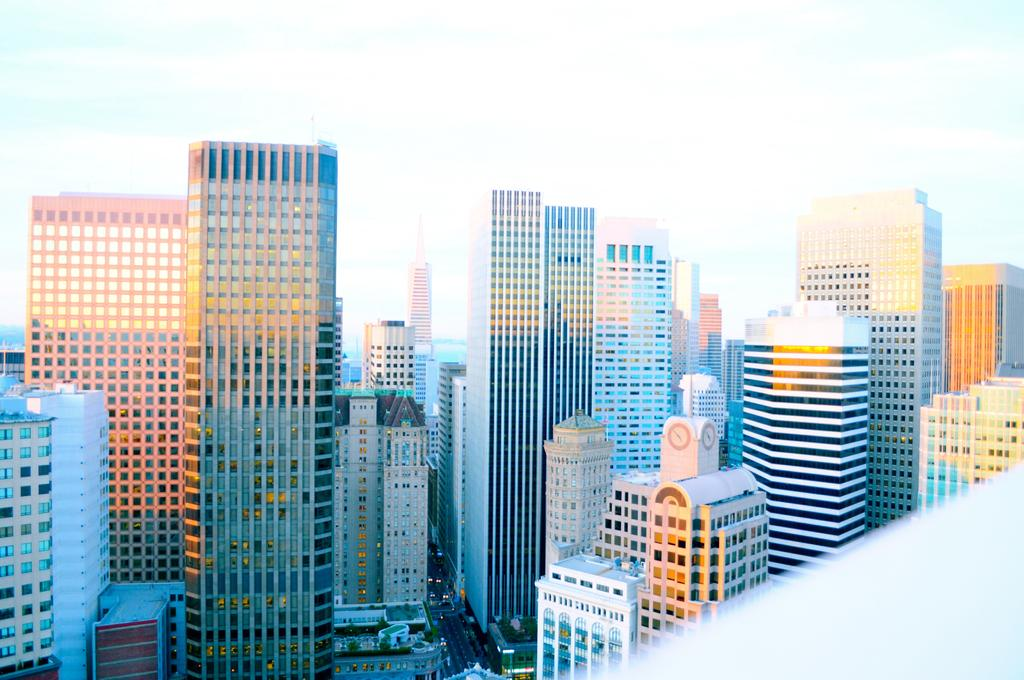What type of structures can be seen in the image? There are buildings with windows in the image. What else is visible on the ground in the image? There are vehicles on the road in the image. What can be seen in the background of the image? The sky is visible in the background of the image. What is the condition of the sky in the image? Clouds are present in the sky. Can you tell me how many pigs are walking on the road in the image? There are no pigs present in the image; it features buildings, vehicles, and clouds in the sky. What type of laborer is working on the buildings in the image? There is no laborer present in the image; it only shows buildings, vehicles, and clouds in the sky. 